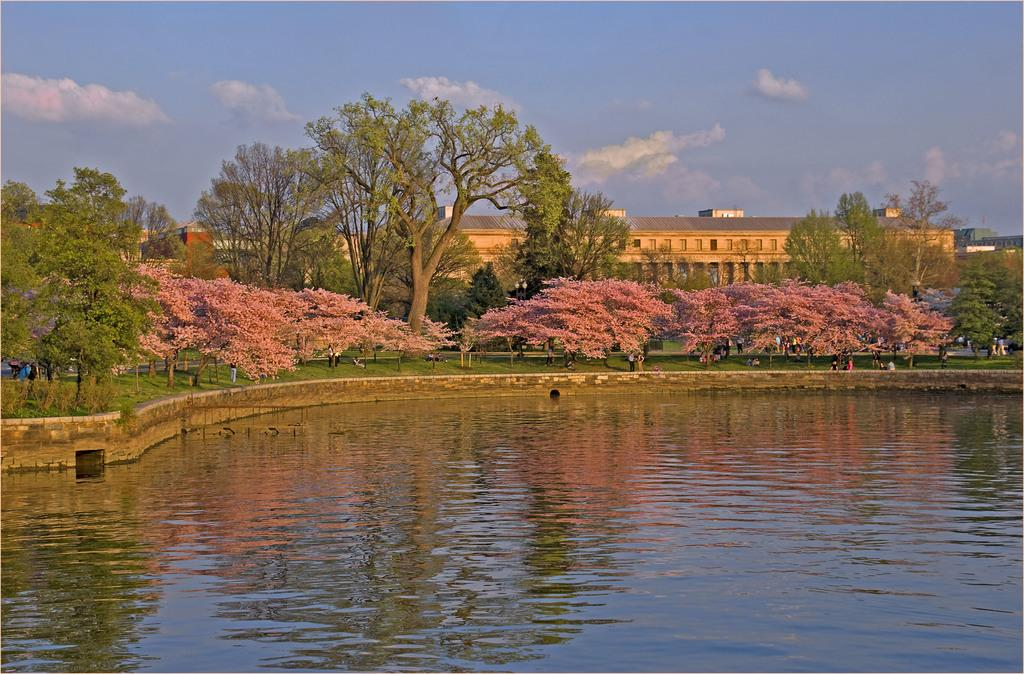What is the main element present in the image? There is water in the image. What other natural elements can be seen in the image? There are trees in the image. Are there any man-made structures visible? Yes, there are buildings in the image. How would you describe the sky in the image? The sky is blue and cloudy. Can you identify any living beings in the image? Yes, there are people visible in the image. What type of goose is being offered to the people in the image? There is no goose present in the image, nor is anything being offered to the people. 